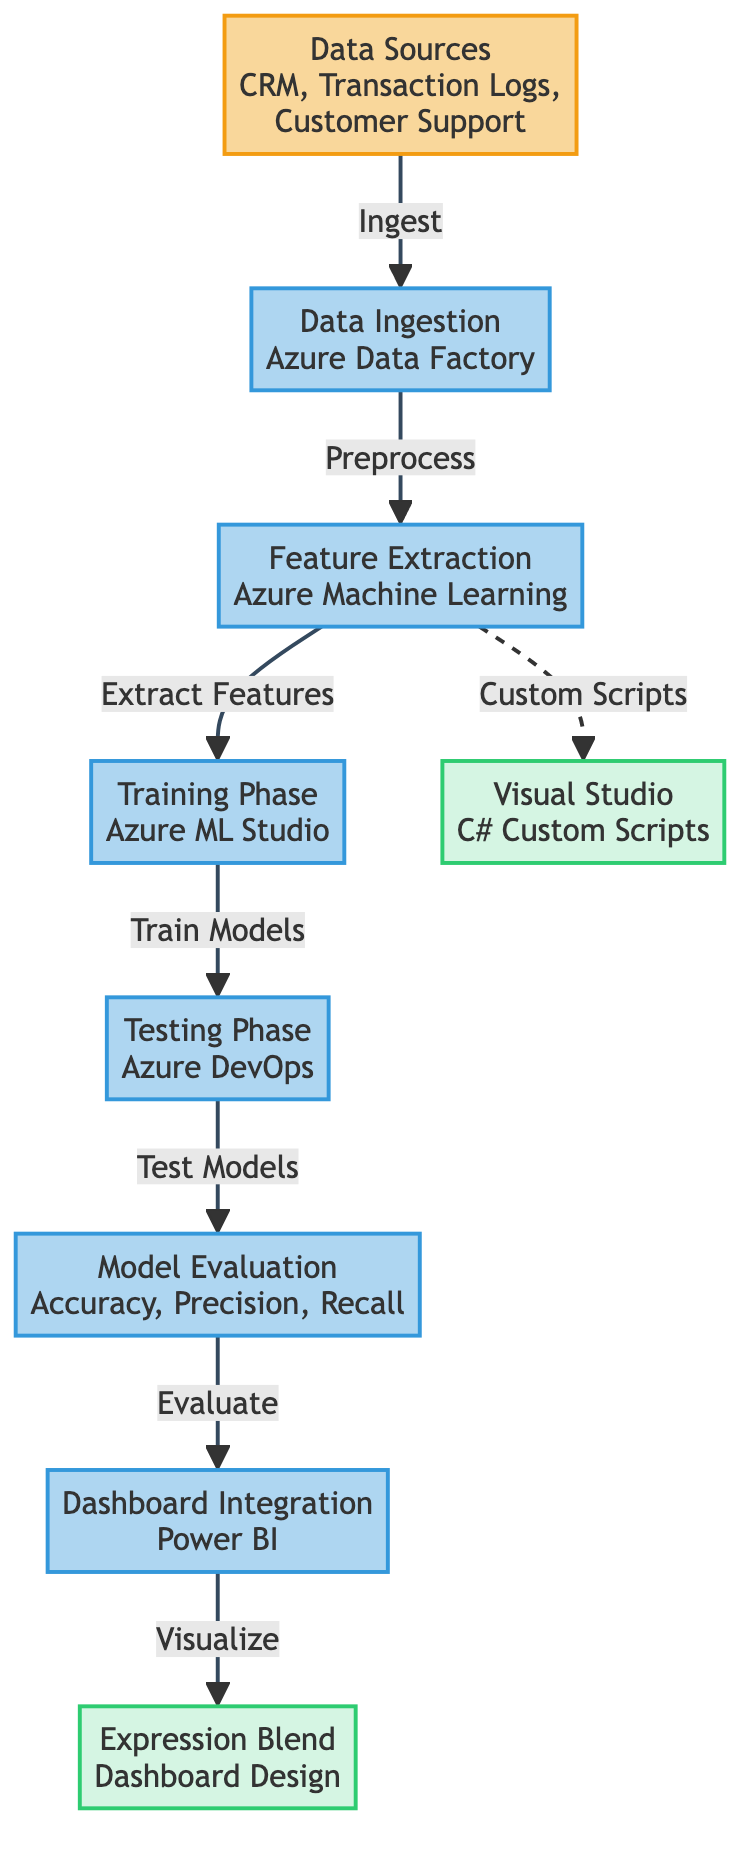What's the first step in the customer churn prediction process? The first step indicated in the diagram is "Data Sources", showing that data is obtained from CRM, Transaction Logs, and Customer Support.
Answer: Data Sources What tool is used for data ingestion? The diagram shows that "Data Ingestion" is managed using "Azure Data Factory", which is responsible for ingesting data from the sources.
Answer: Azure Data Factory How many main phases are involved in the customer churn prediction process? Analyzing the diagram, there are six main phases: Data Ingestion, Feature Extraction, Training Phase, Testing Phase, Model Evaluation, and Dashboard Integration.
Answer: Six Which tool is utilized for model evaluation? In the diagram, the "Model Evaluation" phase involves evaluating metrics such as Accuracy, Precision, and Recall, which are not tied to a specific tool; however, it's a generic process outcome.
Answer: None specified In which phase do the custom scripts from Visual Studio play a role? The diagram illustrates that "Custom Scripts" from "Visual Studio" are linked to the "Feature Extraction" phase, indicating that scripts may be utilized to enhance feature extraction.
Answer: Feature Extraction What follows the testing phase in the process? After the "Testing Phase" in the flowchart, the next step is "Model Evaluation," indicating that models are evaluated following testing to assess their performance.
Answer: Model Evaluation What is the final output in terms of visualization tools used? The diagram concludes with "Dashboard Integration" leading to "Expression Blend", signifying that the final visual output is designed using Expression Blend after integrating the dashboard.
Answer: Expression Blend Which data source is clearly mentioned in the diagram? The diagram specifies several data sources, including CRM and Transaction Logs, indicating where the churn prediction data is sourced.
Answer: CRM What type of data processing occurs before model training? The diagram indicates "Feature Extraction" takes place right before the "Training Phase", suggesting it is crucial to prepare the features before the model training can occur.
Answer: Feature Extraction 